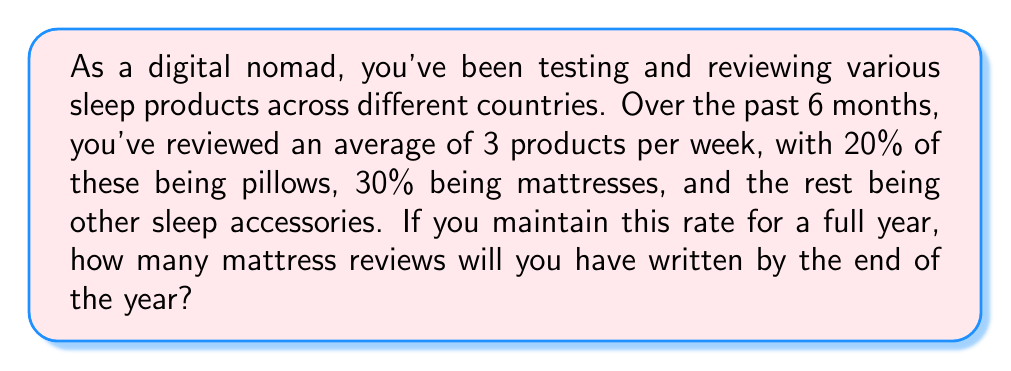What is the answer to this math problem? Let's break this down step-by-step:

1. Calculate the number of products reviewed in a week:
   $$ \text{Products per week} = 3 $$

2. Calculate the number of weeks in a year:
   $$ \text{Weeks in a year} = 52 $$

3. Calculate the total number of products reviewed in a year:
   $$ \text{Total products} = \text{Products per week} \times \text{Weeks in a year} $$
   $$ \text{Total products} = 3 \times 52 = 156 $$

4. Calculate the percentage of mattress reviews:
   $$ \text{Percentage of mattresses} = 30\% = 0.30 $$

5. Calculate the number of mattress reviews:
   $$ \text{Mattress reviews} = \text{Total products} \times \text{Percentage of mattresses} $$
   $$ \text{Mattress reviews} = 156 \times 0.30 = 46.8 $$

6. Since we can't have a fractional review, we round down to the nearest whole number:
   $$ \text{Mattress reviews} = 46 $$
Answer: 46 mattress reviews 